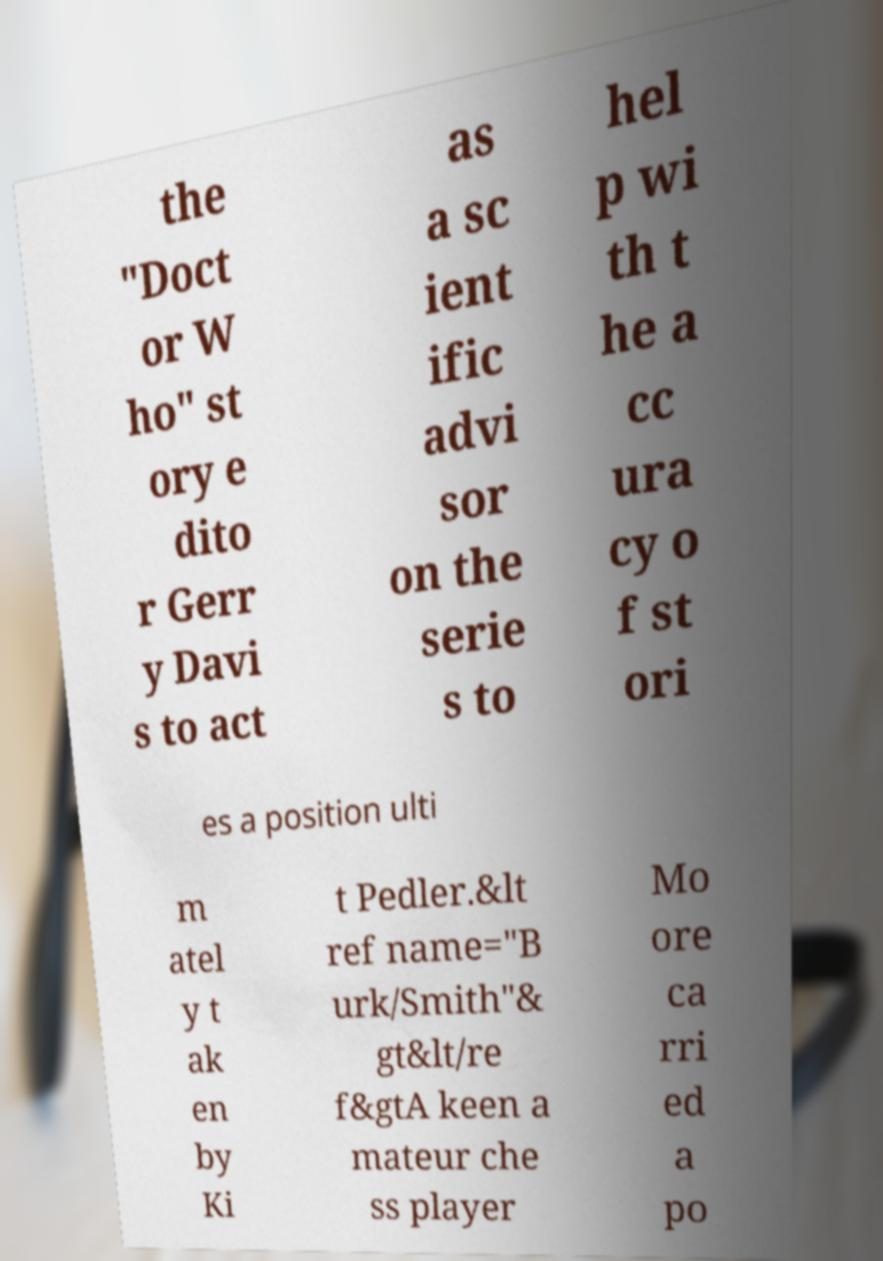What messages or text are displayed in this image? I need them in a readable, typed format. the "Doct or W ho" st ory e dito r Gerr y Davi s to act as a sc ient ific advi sor on the serie s to hel p wi th t he a cc ura cy o f st ori es a position ulti m atel y t ak en by Ki t Pedler.&lt ref name="B urk/Smith"& gt&lt/re f&gtA keen a mateur che ss player Mo ore ca rri ed a po 